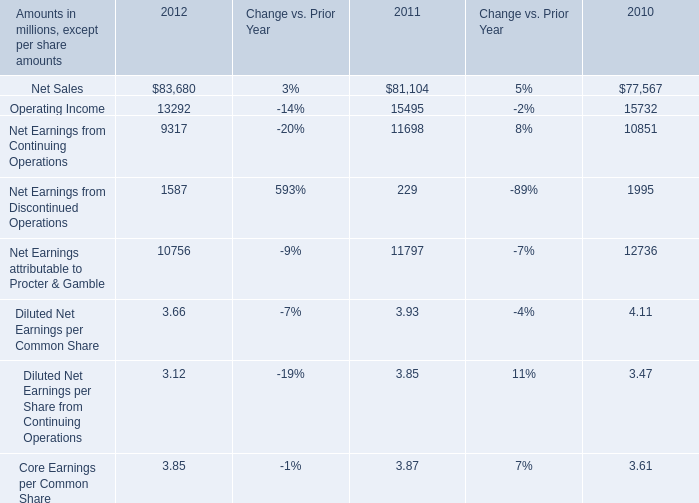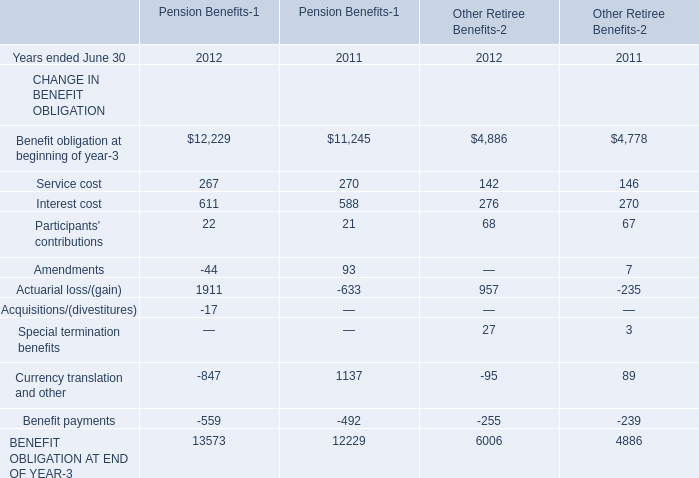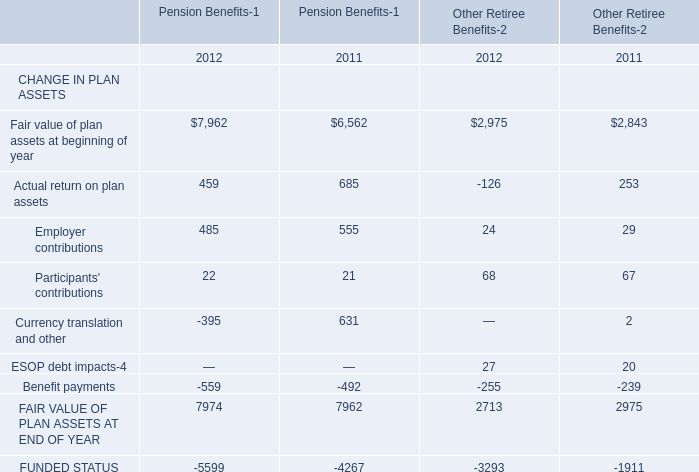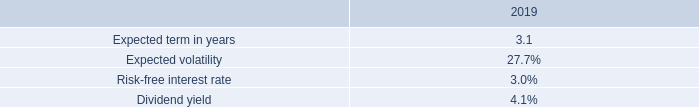Which year is Service cost for pension benefits the lowest? 
Answer: 2012. 